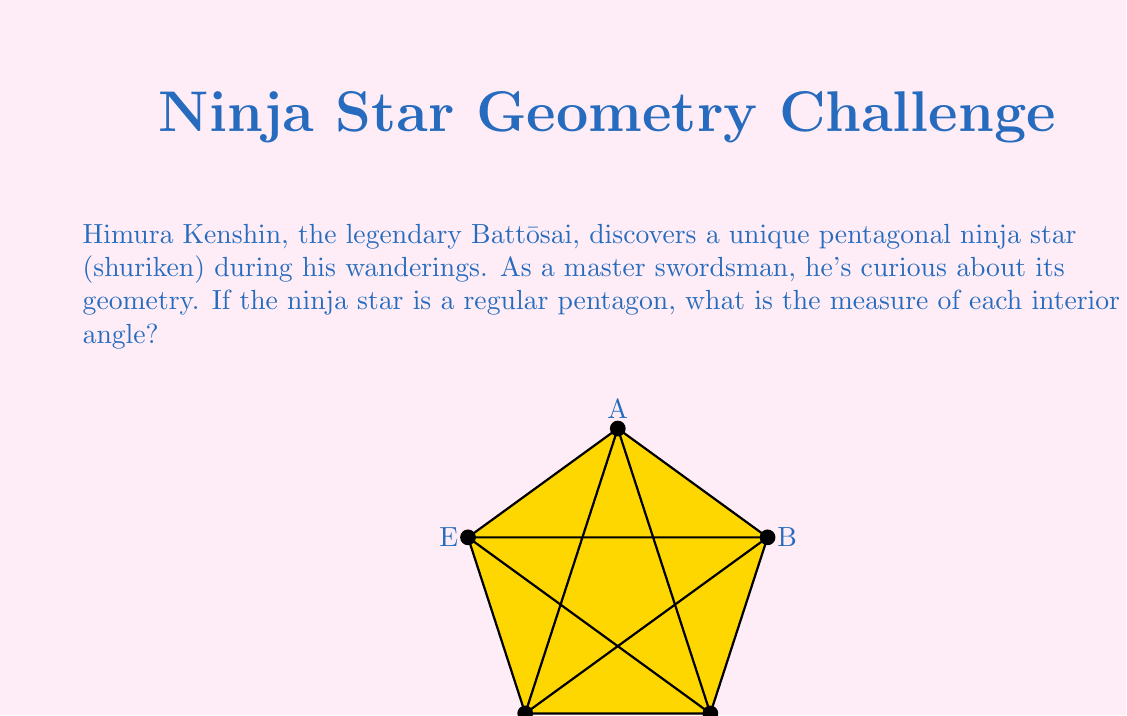Can you answer this question? Let's approach this step-by-step, drawing inspiration from Kenshin's analytical skills:

1) First, recall that the sum of interior angles of any pentagon is given by the formula:
   $$(n-2) \times 180^\circ$$
   where $n$ is the number of sides. For a pentagon, $n = 5$.

2) Substituting this into our formula:
   $$(5-2) \times 180^\circ = 3 \times 180^\circ = 540^\circ$$

3) Since the ninja star is a regular pentagon, all interior angles are equal. To find the measure of each angle, we divide the total by 5:

   $$\frac{540^\circ}{5} = 108^\circ$$

4) We can verify this using the formula for the interior angle of a regular polygon:
   $$\frac{(n-2) \times 180^\circ}{n} = \frac{(5-2) \times 180^\circ}{5} = \frac{540^\circ}{5} = 108^\circ$$

This result of 108° is significant in Japanese culture, as it relates to the 108 earthly desires in Buddhism, a philosophy Kenshin might have encountered in his travels.
Answer: The measure of each interior angle of the regular pentagonal ninja star is $108^\circ$. 